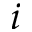Convert formula to latex. <formula><loc_0><loc_0><loc_500><loc_500>i</formula> 